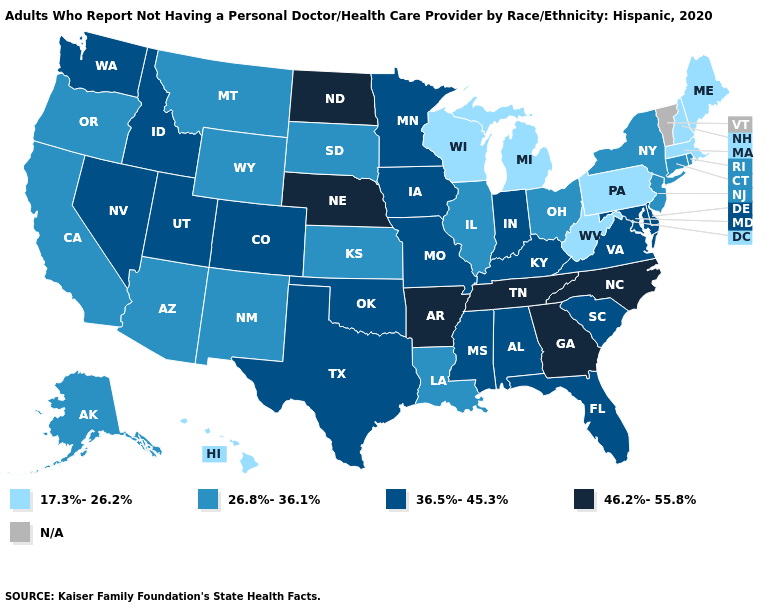Among the states that border Nebraska , does Colorado have the highest value?
Concise answer only. Yes. What is the lowest value in states that border Colorado?
Concise answer only. 26.8%-36.1%. Among the states that border California , does Oregon have the lowest value?
Concise answer only. Yes. Among the states that border Kansas , does Missouri have the highest value?
Keep it brief. No. Which states hav the highest value in the MidWest?
Keep it brief. Nebraska, North Dakota. Name the states that have a value in the range 36.5%-45.3%?
Keep it brief. Alabama, Colorado, Delaware, Florida, Idaho, Indiana, Iowa, Kentucky, Maryland, Minnesota, Mississippi, Missouri, Nevada, Oklahoma, South Carolina, Texas, Utah, Virginia, Washington. What is the value of Vermont?
Write a very short answer. N/A. Does the first symbol in the legend represent the smallest category?
Concise answer only. Yes. What is the highest value in the West ?
Be succinct. 36.5%-45.3%. What is the value of West Virginia?
Answer briefly. 17.3%-26.2%. What is the highest value in states that border Iowa?
Answer briefly. 46.2%-55.8%. Name the states that have a value in the range N/A?
Write a very short answer. Vermont. 